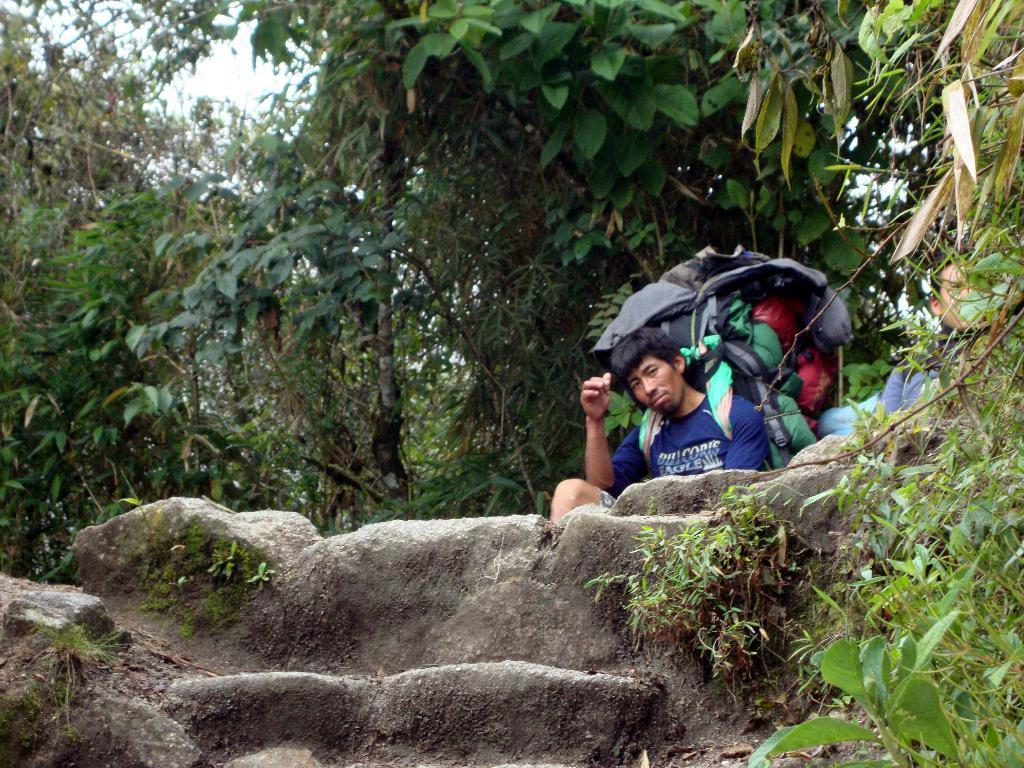Please provide a concise description of this image. In this image there is a man, he is wearing a bag in the background there are trees. 